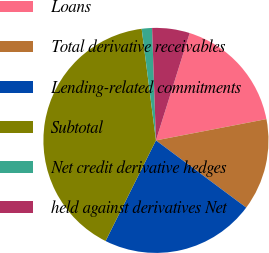<chart> <loc_0><loc_0><loc_500><loc_500><pie_chart><fcel>Loans<fcel>Total derivative receivables<fcel>Lending-related commitments<fcel>Subtotal<fcel>Net credit derivative hedges<fcel>held against derivatives Net<nl><fcel>17.12%<fcel>13.21%<fcel>22.2%<fcel>40.58%<fcel>1.48%<fcel>5.39%<nl></chart> 